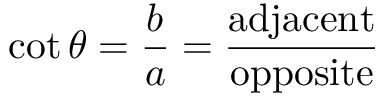<formula> <loc_0><loc_0><loc_500><loc_500>\cot \theta = { \frac { b } { a } } = { \frac { a d j a c e n t } { o p p o s i t e } }</formula> 